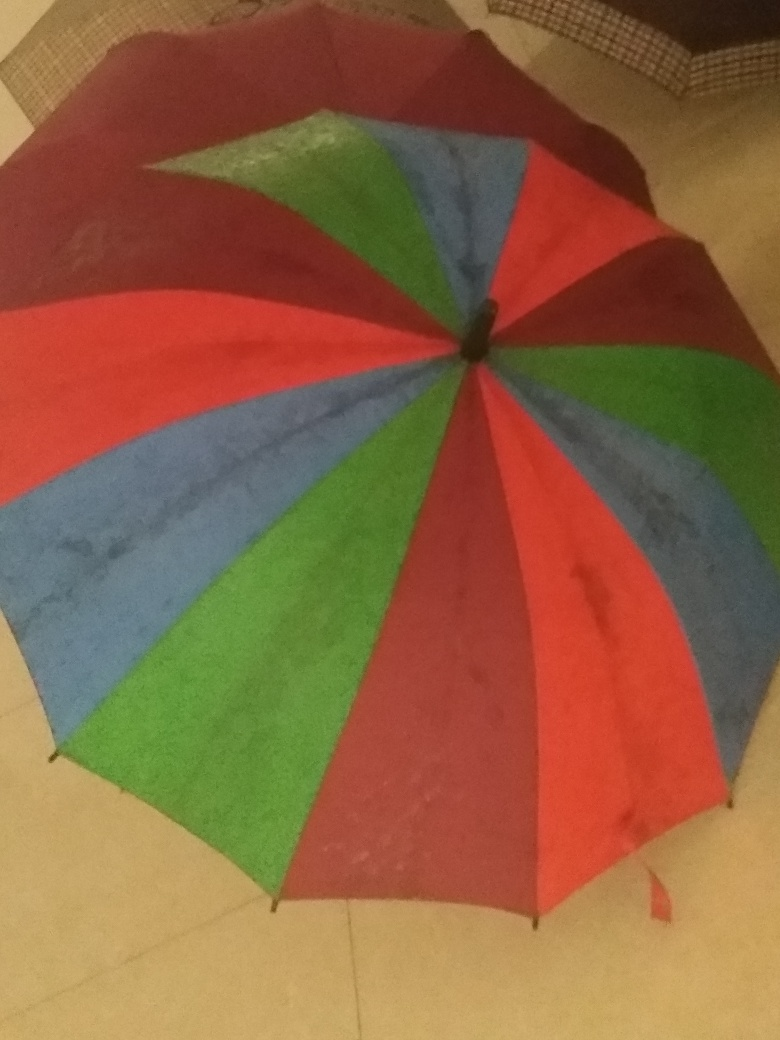Can you describe the item in the picture? Sure, the image depicts a multicolored umbrella lying on the ground, open but not in use. It features a vibrant array of colors including red, blue, and green sections.  Could you tell me the possible uses for this item? Certainly, an umbrella like the one pictured is primarily used for protection against rain or as a shield from the sun. It can also be used as a fashion accessory or for outdoor decorations during events. 